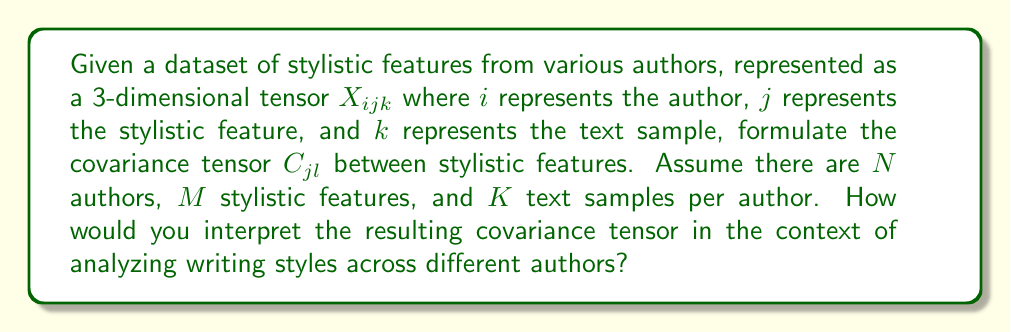Help me with this question. To determine the covariance tensor of stylistic features across different authors, we'll follow these steps:

1. Calculate the mean of each stylistic feature across all authors and text samples:
   $$\mu_j = \frac{1}{NKM} \sum_{i=1}^N \sum_{k=1}^K X_{ijk}$$

2. Center the data by subtracting the mean from each element:
   $$X'_{ijk} = X_{ijk} - \mu_j$$

3. Formulate the covariance tensor:
   $$C_{jl} = \frac{1}{NK-1} \sum_{i=1}^N \sum_{k=1}^K X'_{ijk} X'_{ilk}$$

4. Interpret the resulting covariance tensor:
   - Each element $C_{jl}$ represents the covariance between stylistic features $j$ and $l$.
   - Diagonal elements $C_{jj}$ represent the variance of feature $j$.
   - Off-diagonal elements $C_{jl}$ (where $j \neq l$) represent the covariance between features $j$ and $l$.
   - Positive values indicate features that tend to vary together.
   - Negative values indicate features that tend to vary inversely.
   - Values close to zero suggest little to no linear relationship between features.

5. In the context of analyzing writing styles:
   - High positive covariance between two features suggests they are often used together by authors.
   - High negative covariance suggests authors who use one feature tend to avoid the other.
   - Low covariance suggests the features are used independently of each other.

This covariance tensor provides insights into the relationships between different stylistic features across authors, helping to identify patterns and similarities in writing styles.
Answer: $C_{jl} = \frac{1}{NK-1} \sum_{i=1}^N \sum_{k=1}^K (X_{ijk} - \mu_j)(X_{ilk} - \mu_l)$ 